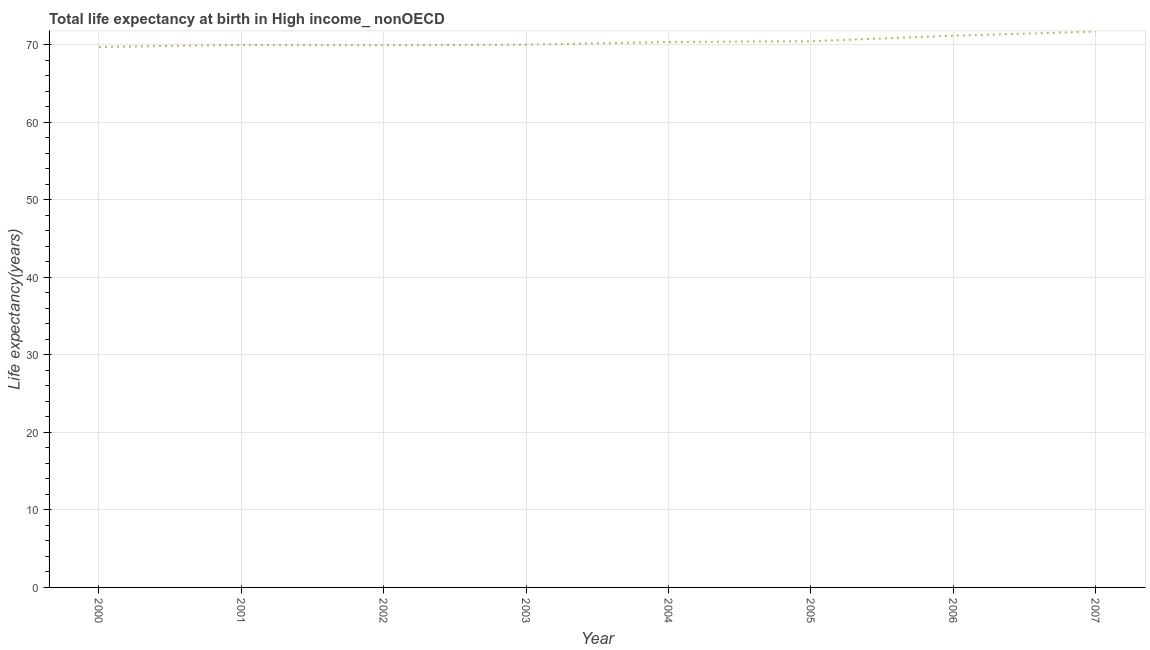What is the life expectancy at birth in 2005?
Your response must be concise. 70.48. Across all years, what is the maximum life expectancy at birth?
Offer a very short reply. 71.72. Across all years, what is the minimum life expectancy at birth?
Your response must be concise. 69.75. In which year was the life expectancy at birth minimum?
Offer a terse response. 2000. What is the sum of the life expectancy at birth?
Keep it short and to the point. 563.52. What is the difference between the life expectancy at birth in 2000 and 2002?
Your response must be concise. -0.21. What is the average life expectancy at birth per year?
Ensure brevity in your answer.  70.44. What is the median life expectancy at birth?
Keep it short and to the point. 70.21. In how many years, is the life expectancy at birth greater than 8 years?
Offer a terse response. 8. What is the ratio of the life expectancy at birth in 2001 to that in 2005?
Your answer should be compact. 0.99. Is the life expectancy at birth in 2003 less than that in 2006?
Your response must be concise. Yes. What is the difference between the highest and the second highest life expectancy at birth?
Your response must be concise. 0.53. Is the sum of the life expectancy at birth in 2001 and 2005 greater than the maximum life expectancy at birth across all years?
Your answer should be very brief. Yes. What is the difference between the highest and the lowest life expectancy at birth?
Offer a very short reply. 1.98. In how many years, is the life expectancy at birth greater than the average life expectancy at birth taken over all years?
Ensure brevity in your answer.  3. Does the life expectancy at birth monotonically increase over the years?
Keep it short and to the point. No. How many lines are there?
Your answer should be compact. 1. How many years are there in the graph?
Your answer should be compact. 8. Does the graph contain grids?
Your answer should be compact. Yes. What is the title of the graph?
Provide a succinct answer. Total life expectancy at birth in High income_ nonOECD. What is the label or title of the Y-axis?
Your answer should be very brief. Life expectancy(years). What is the Life expectancy(years) in 2000?
Provide a succinct answer. 69.75. What is the Life expectancy(years) of 2001?
Make the answer very short. 70. What is the Life expectancy(years) of 2002?
Your answer should be very brief. 69.96. What is the Life expectancy(years) in 2003?
Provide a succinct answer. 70.04. What is the Life expectancy(years) in 2004?
Provide a succinct answer. 70.38. What is the Life expectancy(years) in 2005?
Keep it short and to the point. 70.48. What is the Life expectancy(years) of 2006?
Keep it short and to the point. 71.2. What is the Life expectancy(years) in 2007?
Your answer should be compact. 71.72. What is the difference between the Life expectancy(years) in 2000 and 2001?
Provide a short and direct response. -0.25. What is the difference between the Life expectancy(years) in 2000 and 2002?
Provide a succinct answer. -0.21. What is the difference between the Life expectancy(years) in 2000 and 2003?
Offer a terse response. -0.29. What is the difference between the Life expectancy(years) in 2000 and 2004?
Make the answer very short. -0.64. What is the difference between the Life expectancy(years) in 2000 and 2005?
Ensure brevity in your answer.  -0.74. What is the difference between the Life expectancy(years) in 2000 and 2006?
Ensure brevity in your answer.  -1.45. What is the difference between the Life expectancy(years) in 2000 and 2007?
Provide a succinct answer. -1.98. What is the difference between the Life expectancy(years) in 2001 and 2002?
Your answer should be very brief. 0.04. What is the difference between the Life expectancy(years) in 2001 and 2003?
Provide a short and direct response. -0.04. What is the difference between the Life expectancy(years) in 2001 and 2004?
Your answer should be very brief. -0.38. What is the difference between the Life expectancy(years) in 2001 and 2005?
Offer a very short reply. -0.48. What is the difference between the Life expectancy(years) in 2001 and 2006?
Give a very brief answer. -1.2. What is the difference between the Life expectancy(years) in 2001 and 2007?
Keep it short and to the point. -1.73. What is the difference between the Life expectancy(years) in 2002 and 2003?
Provide a succinct answer. -0.08. What is the difference between the Life expectancy(years) in 2002 and 2004?
Your answer should be very brief. -0.42. What is the difference between the Life expectancy(years) in 2002 and 2005?
Provide a short and direct response. -0.52. What is the difference between the Life expectancy(years) in 2002 and 2006?
Offer a very short reply. -1.24. What is the difference between the Life expectancy(years) in 2002 and 2007?
Provide a short and direct response. -1.77. What is the difference between the Life expectancy(years) in 2003 and 2004?
Offer a terse response. -0.35. What is the difference between the Life expectancy(years) in 2003 and 2005?
Your response must be concise. -0.45. What is the difference between the Life expectancy(years) in 2003 and 2006?
Your response must be concise. -1.16. What is the difference between the Life expectancy(years) in 2003 and 2007?
Your answer should be very brief. -1.69. What is the difference between the Life expectancy(years) in 2004 and 2005?
Give a very brief answer. -0.1. What is the difference between the Life expectancy(years) in 2004 and 2006?
Your response must be concise. -0.81. What is the difference between the Life expectancy(years) in 2004 and 2007?
Provide a succinct answer. -1.34. What is the difference between the Life expectancy(years) in 2005 and 2006?
Your answer should be compact. -0.71. What is the difference between the Life expectancy(years) in 2005 and 2007?
Offer a very short reply. -1.24. What is the difference between the Life expectancy(years) in 2006 and 2007?
Give a very brief answer. -0.53. What is the ratio of the Life expectancy(years) in 2000 to that in 2002?
Give a very brief answer. 1. What is the ratio of the Life expectancy(years) in 2000 to that in 2003?
Offer a terse response. 1. What is the ratio of the Life expectancy(years) in 2000 to that in 2004?
Keep it short and to the point. 0.99. What is the ratio of the Life expectancy(years) in 2000 to that in 2006?
Make the answer very short. 0.98. What is the ratio of the Life expectancy(years) in 2000 to that in 2007?
Provide a short and direct response. 0.97. What is the ratio of the Life expectancy(years) in 2001 to that in 2004?
Offer a very short reply. 0.99. What is the ratio of the Life expectancy(years) in 2002 to that in 2003?
Offer a very short reply. 1. What is the ratio of the Life expectancy(years) in 2002 to that in 2004?
Provide a succinct answer. 0.99. What is the ratio of the Life expectancy(years) in 2003 to that in 2004?
Offer a very short reply. 0.99. What is the ratio of the Life expectancy(years) in 2004 to that in 2006?
Offer a terse response. 0.99. What is the ratio of the Life expectancy(years) in 2006 to that in 2007?
Offer a terse response. 0.99. 